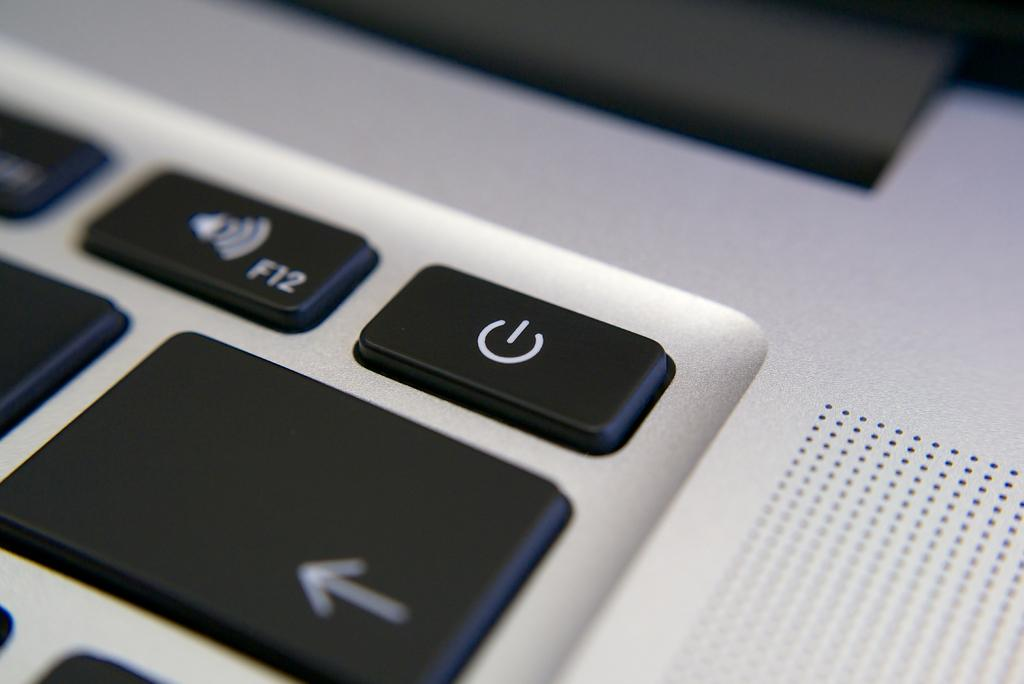What is the main object in the image? There is a keyboard in the image. What might the keyboard be used for? The keyboard is likely used for typing or inputting data. Can you describe the appearance of the keyboard? The image only shows a keyboard, so it is difficult to provide a detailed description of its appearance. What type of stem is growing from the keyboard in the image? There is no stem growing from the keyboard in the image. What is the level of interest in the keyboard among computer enthusiasts? The image does not provide any information about the level of interest in the keyboard among computer enthusiasts. 